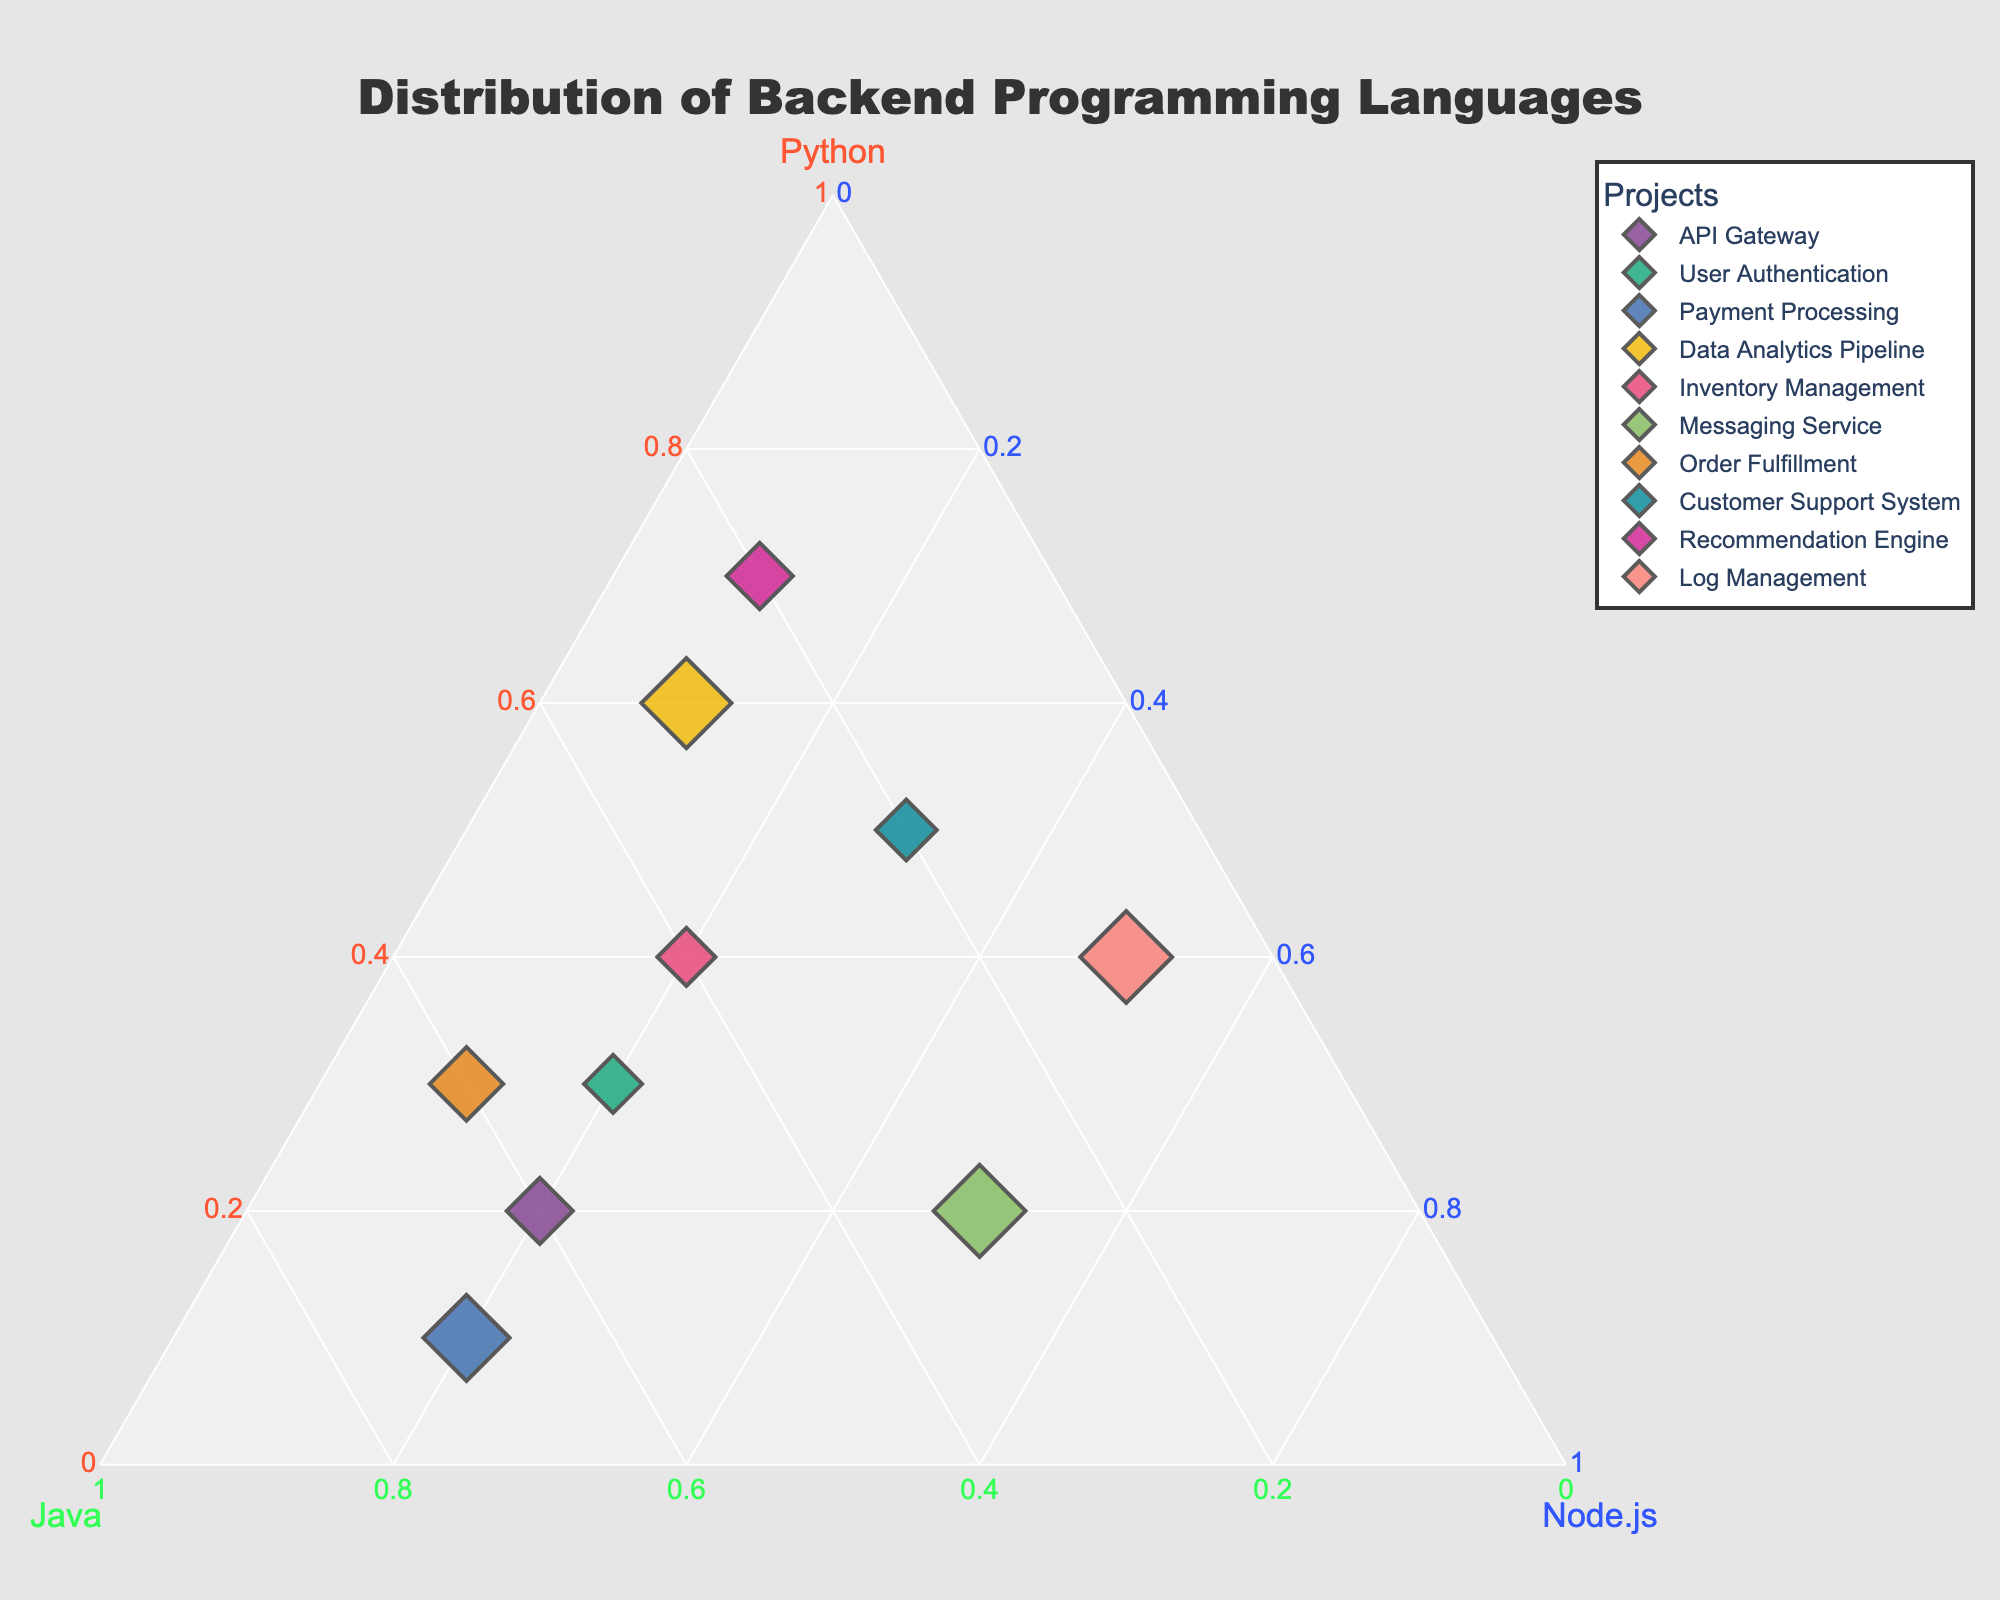How many projects are displayed in the ternary plot? Count the number of unique data points in the plot. Each data point represents one project.
Answer: 10 Which project shows the highest proportion of Python usage? Identify the data point closest to the Python axis's 100% mark. The project closest to this point has the highest proportion of Python usage.
Answer: Recommendation Engine What is the average proportion of Java usage across all projects? Add the Java proportions for all projects and divide by the number of projects. (0.6 + 0.5 + 0.7 + 0.3 + 0.4 + 0.3 + 0.6 + 0.2 + 0.2 + 0.1) / 10 = 3.9 / 10
Answer: 0.39 Which project has an equal proportion of Python and Java usage? Find the data point equidistant from both the Python and Java axes. This project will lie along the line that represents equal proportion of both languages.
Answer: Inventory Management Among all projects, which one has the highest Node.js usage? Identify the data point closest to the Node.js axis's 100% mark. This project uses the highest proportion of Node.js.
Answer: Messaging Service What is the ratio of Python to Node.js in the Log Management project? Compare the proportions of Python and Node.js for Log Management. Python = 0.4, Node.js = 0.5. The ratio is 0.4 to 0.5.
Answer: 0.8 Which project is the second closest to having an even distribution of all three languages? Find the second closest data point to the center of the plot, where the distribution of all three programming languages is 1/3 each.
Answer: API Gateway Is the Payment Processing project more Java-heavy or Python-heavy? Compare the proportions of Java (0.7) and Python (0.1) for Payment Processing. Since 0.7 > 0.1, it is more Java-heavy.
Answer: Java-heavy What is the total proportion of languages used in Data Analytics Pipeline for Java and Node.js? Add the proportions of Java and Node.js for the Data Analytics Pipeline project. Java = 0.3, Node.js = 0.1. Total = 0.3 + 0.1
Answer: 0.4 